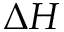Convert formula to latex. <formula><loc_0><loc_0><loc_500><loc_500>\Delta H</formula> 